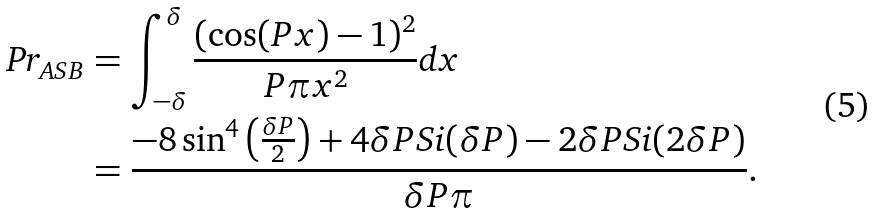Convert formula to latex. <formula><loc_0><loc_0><loc_500><loc_500>\text {Pr} _ { A S B } & = \int _ { - \delta } ^ { \delta } \frac { ( \cos ( P x ) - 1 ) ^ { 2 } } { P \pi x ^ { 2 } } \text {d} x \\ & = \frac { - 8 \sin ^ { 4 } \left ( \frac { \delta P } { 2 } \right ) + 4 \delta P \text {Si} ( \delta P ) - 2 \delta P \text {Si} ( 2 \delta P ) } { \delta P \pi } .</formula> 